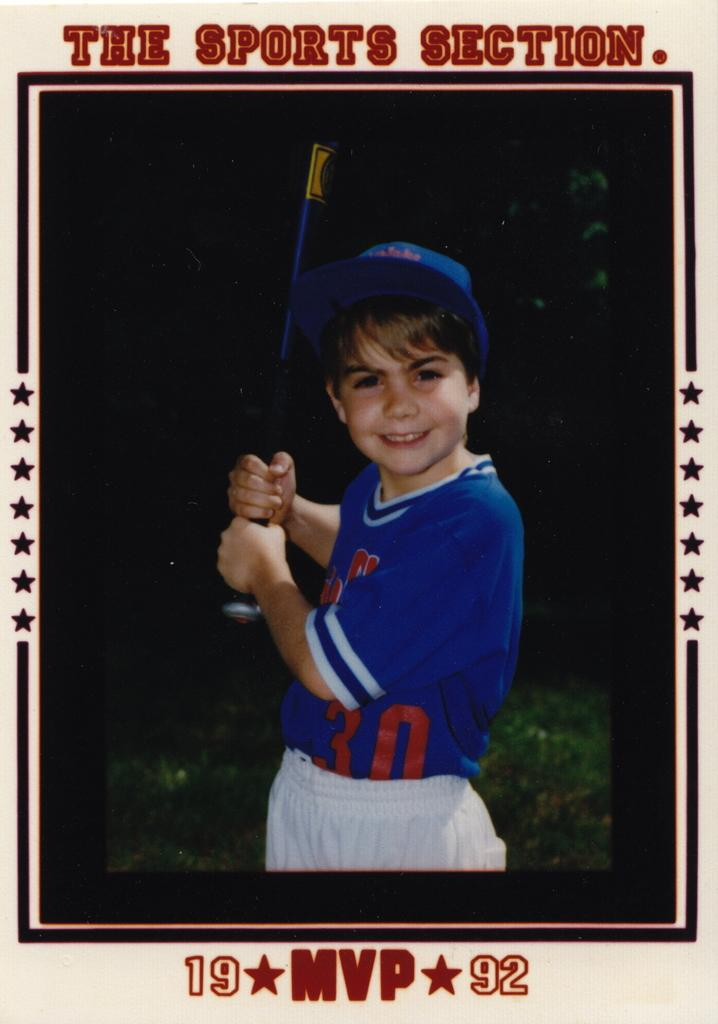Provide a one-sentence caption for the provided image. A baseball card-style photo shows a young boy wearing the number 30. 